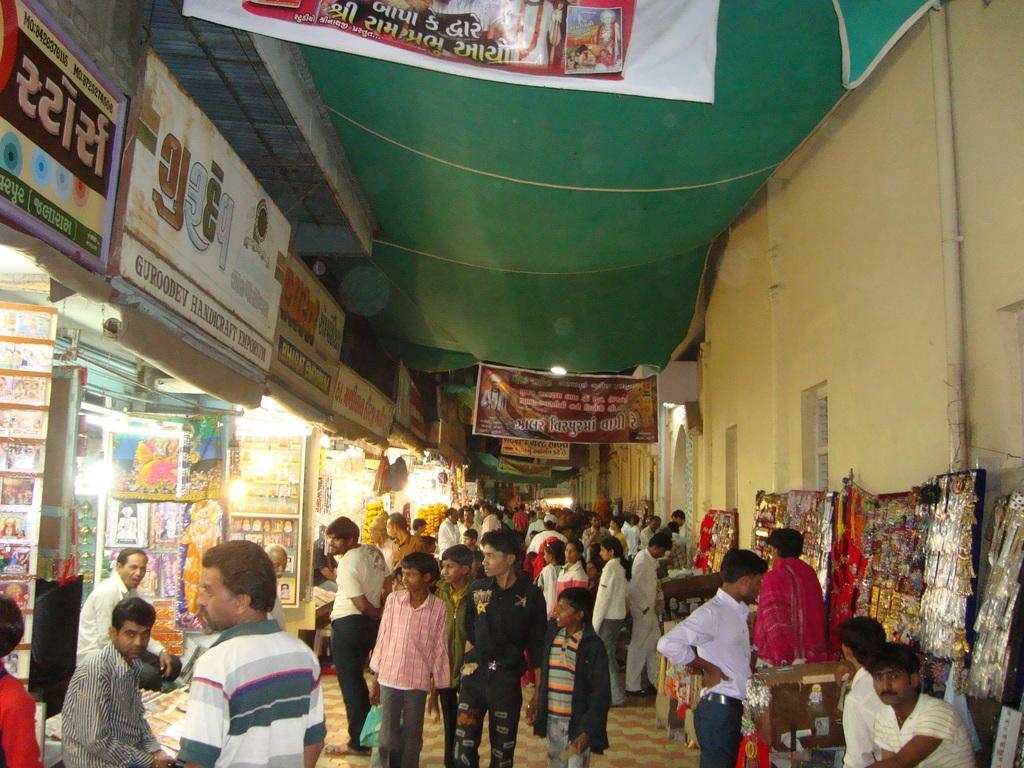Could you give a brief overview of what you see in this image? In this image there are stalls with some text boards and people in the left corner. There are people, stalls, and wall in the right corner. There are people in the foreground. There are people and posters in the background. There is floor at the bottom. And there is a roof at the top. 